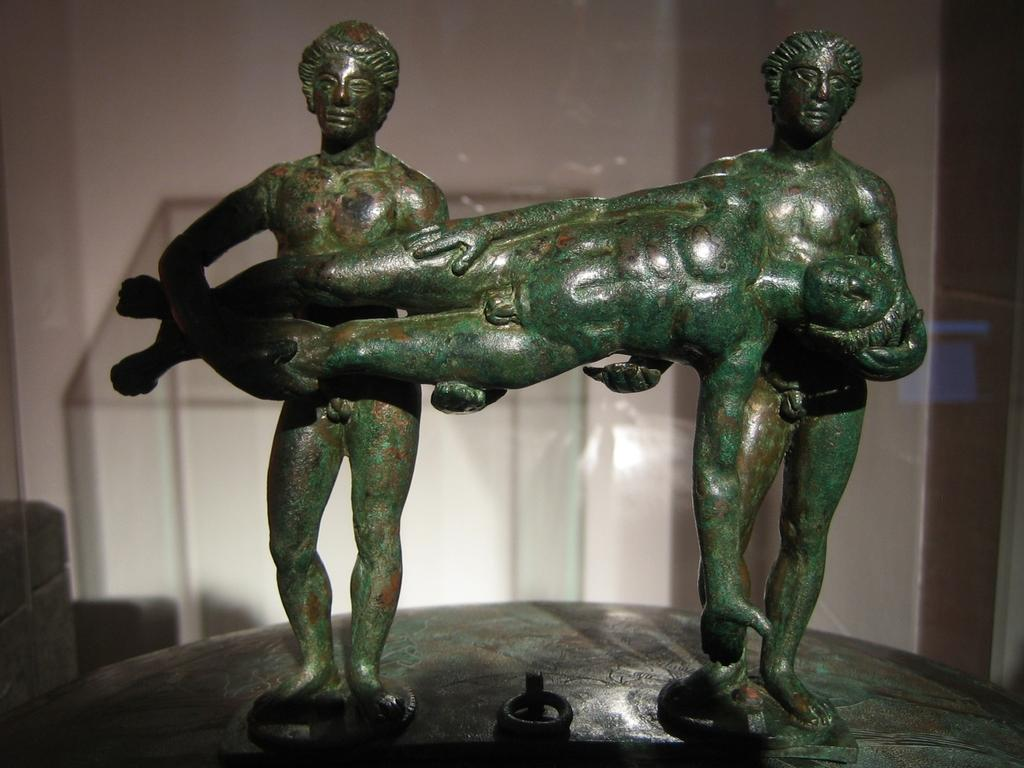What type of artwork is present in the image? There are sculptures in the image. Where are the sculptures located? The sculptures are on a pedestal. What can be seen in the background of the image? There is a glass and a wall visible in the background of the image. What type of haircut does the doll have in the image? There is no doll present in the image, so it is not possible to answer that question. 